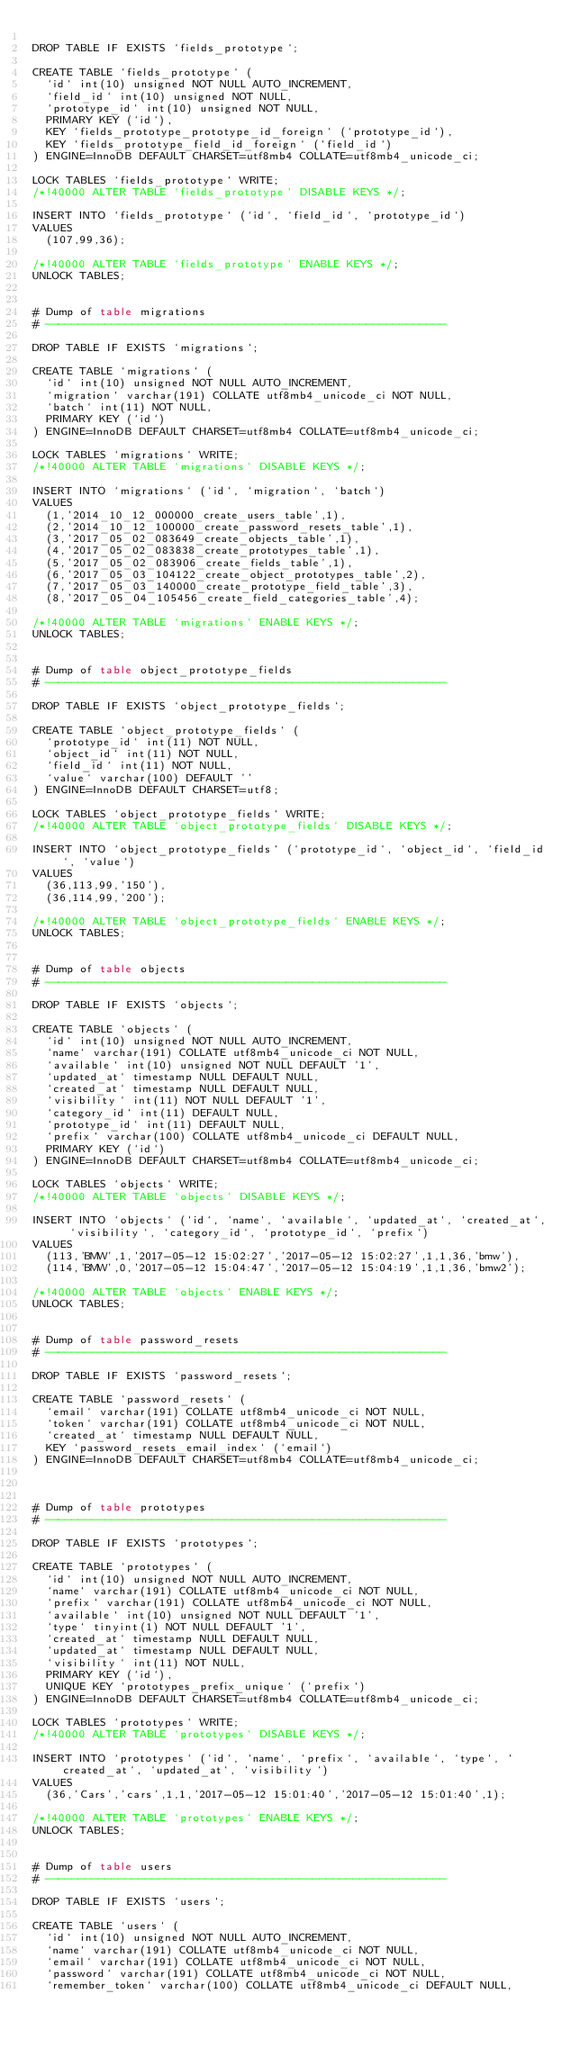<code> <loc_0><loc_0><loc_500><loc_500><_SQL_>
DROP TABLE IF EXISTS `fields_prototype`;

CREATE TABLE `fields_prototype` (
  `id` int(10) unsigned NOT NULL AUTO_INCREMENT,
  `field_id` int(10) unsigned NOT NULL,
  `prototype_id` int(10) unsigned NOT NULL,
  PRIMARY KEY (`id`),
  KEY `fields_prototype_prototype_id_foreign` (`prototype_id`),
  KEY `fields_prototype_field_id_foreign` (`field_id`)
) ENGINE=InnoDB DEFAULT CHARSET=utf8mb4 COLLATE=utf8mb4_unicode_ci;

LOCK TABLES `fields_prototype` WRITE;
/*!40000 ALTER TABLE `fields_prototype` DISABLE KEYS */;

INSERT INTO `fields_prototype` (`id`, `field_id`, `prototype_id`)
VALUES
	(107,99,36);

/*!40000 ALTER TABLE `fields_prototype` ENABLE KEYS */;
UNLOCK TABLES;


# Dump of table migrations
# ------------------------------------------------------------

DROP TABLE IF EXISTS `migrations`;

CREATE TABLE `migrations` (
  `id` int(10) unsigned NOT NULL AUTO_INCREMENT,
  `migration` varchar(191) COLLATE utf8mb4_unicode_ci NOT NULL,
  `batch` int(11) NOT NULL,
  PRIMARY KEY (`id`)
) ENGINE=InnoDB DEFAULT CHARSET=utf8mb4 COLLATE=utf8mb4_unicode_ci;

LOCK TABLES `migrations` WRITE;
/*!40000 ALTER TABLE `migrations` DISABLE KEYS */;

INSERT INTO `migrations` (`id`, `migration`, `batch`)
VALUES
	(1,'2014_10_12_000000_create_users_table',1),
	(2,'2014_10_12_100000_create_password_resets_table',1),
	(3,'2017_05_02_083649_create_objects_table',1),
	(4,'2017_05_02_083838_create_prototypes_table',1),
	(5,'2017_05_02_083906_create_fields_table',1),
	(6,'2017_05_03_104122_create_object_prototypes_table',2),
	(7,'2017_05_03_140000_create_prototype_field_table',3),
	(8,'2017_05_04_105456_create_field_categories_table',4);

/*!40000 ALTER TABLE `migrations` ENABLE KEYS */;
UNLOCK TABLES;


# Dump of table object_prototype_fields
# ------------------------------------------------------------

DROP TABLE IF EXISTS `object_prototype_fields`;

CREATE TABLE `object_prototype_fields` (
  `prototype_id` int(11) NOT NULL,
  `object_id` int(11) NOT NULL,
  `field_id` int(11) NOT NULL,
  `value` varchar(100) DEFAULT ''
) ENGINE=InnoDB DEFAULT CHARSET=utf8;

LOCK TABLES `object_prototype_fields` WRITE;
/*!40000 ALTER TABLE `object_prototype_fields` DISABLE KEYS */;

INSERT INTO `object_prototype_fields` (`prototype_id`, `object_id`, `field_id`, `value`)
VALUES
	(36,113,99,'150'),
	(36,114,99,'200');

/*!40000 ALTER TABLE `object_prototype_fields` ENABLE KEYS */;
UNLOCK TABLES;


# Dump of table objects
# ------------------------------------------------------------

DROP TABLE IF EXISTS `objects`;

CREATE TABLE `objects` (
  `id` int(10) unsigned NOT NULL AUTO_INCREMENT,
  `name` varchar(191) COLLATE utf8mb4_unicode_ci NOT NULL,
  `available` int(10) unsigned NOT NULL DEFAULT '1',
  `updated_at` timestamp NULL DEFAULT NULL,
  `created_at` timestamp NULL DEFAULT NULL,
  `visibility` int(11) NOT NULL DEFAULT '1',
  `category_id` int(11) DEFAULT NULL,
  `prototype_id` int(11) DEFAULT NULL,
  `prefix` varchar(100) COLLATE utf8mb4_unicode_ci DEFAULT NULL,
  PRIMARY KEY (`id`)
) ENGINE=InnoDB DEFAULT CHARSET=utf8mb4 COLLATE=utf8mb4_unicode_ci;

LOCK TABLES `objects` WRITE;
/*!40000 ALTER TABLE `objects` DISABLE KEYS */;

INSERT INTO `objects` (`id`, `name`, `available`, `updated_at`, `created_at`, `visibility`, `category_id`, `prototype_id`, `prefix`)
VALUES
	(113,'BMW',1,'2017-05-12 15:02:27','2017-05-12 15:02:27',1,1,36,'bmw'),
	(114,'BMW',0,'2017-05-12 15:04:47','2017-05-12 15:04:19',1,1,36,'bmw2');

/*!40000 ALTER TABLE `objects` ENABLE KEYS */;
UNLOCK TABLES;


# Dump of table password_resets
# ------------------------------------------------------------

DROP TABLE IF EXISTS `password_resets`;

CREATE TABLE `password_resets` (
  `email` varchar(191) COLLATE utf8mb4_unicode_ci NOT NULL,
  `token` varchar(191) COLLATE utf8mb4_unicode_ci NOT NULL,
  `created_at` timestamp NULL DEFAULT NULL,
  KEY `password_resets_email_index` (`email`)
) ENGINE=InnoDB DEFAULT CHARSET=utf8mb4 COLLATE=utf8mb4_unicode_ci;



# Dump of table prototypes
# ------------------------------------------------------------

DROP TABLE IF EXISTS `prototypes`;

CREATE TABLE `prototypes` (
  `id` int(10) unsigned NOT NULL AUTO_INCREMENT,
  `name` varchar(191) COLLATE utf8mb4_unicode_ci NOT NULL,
  `prefix` varchar(191) COLLATE utf8mb4_unicode_ci NOT NULL,
  `available` int(10) unsigned NOT NULL DEFAULT '1',
  `type` tinyint(1) NOT NULL DEFAULT '1',
  `created_at` timestamp NULL DEFAULT NULL,
  `updated_at` timestamp NULL DEFAULT NULL,
  `visibility` int(11) NOT NULL,
  PRIMARY KEY (`id`),
  UNIQUE KEY `prototypes_prefix_unique` (`prefix`)
) ENGINE=InnoDB DEFAULT CHARSET=utf8mb4 COLLATE=utf8mb4_unicode_ci;

LOCK TABLES `prototypes` WRITE;
/*!40000 ALTER TABLE `prototypes` DISABLE KEYS */;

INSERT INTO `prototypes` (`id`, `name`, `prefix`, `available`, `type`, `created_at`, `updated_at`, `visibility`)
VALUES
	(36,'Cars','cars',1,1,'2017-05-12 15:01:40','2017-05-12 15:01:40',1);

/*!40000 ALTER TABLE `prototypes` ENABLE KEYS */;
UNLOCK TABLES;


# Dump of table users
# ------------------------------------------------------------

DROP TABLE IF EXISTS `users`;

CREATE TABLE `users` (
  `id` int(10) unsigned NOT NULL AUTO_INCREMENT,
  `name` varchar(191) COLLATE utf8mb4_unicode_ci NOT NULL,
  `email` varchar(191) COLLATE utf8mb4_unicode_ci NOT NULL,
  `password` varchar(191) COLLATE utf8mb4_unicode_ci NOT NULL,
  `remember_token` varchar(100) COLLATE utf8mb4_unicode_ci DEFAULT NULL,</code> 